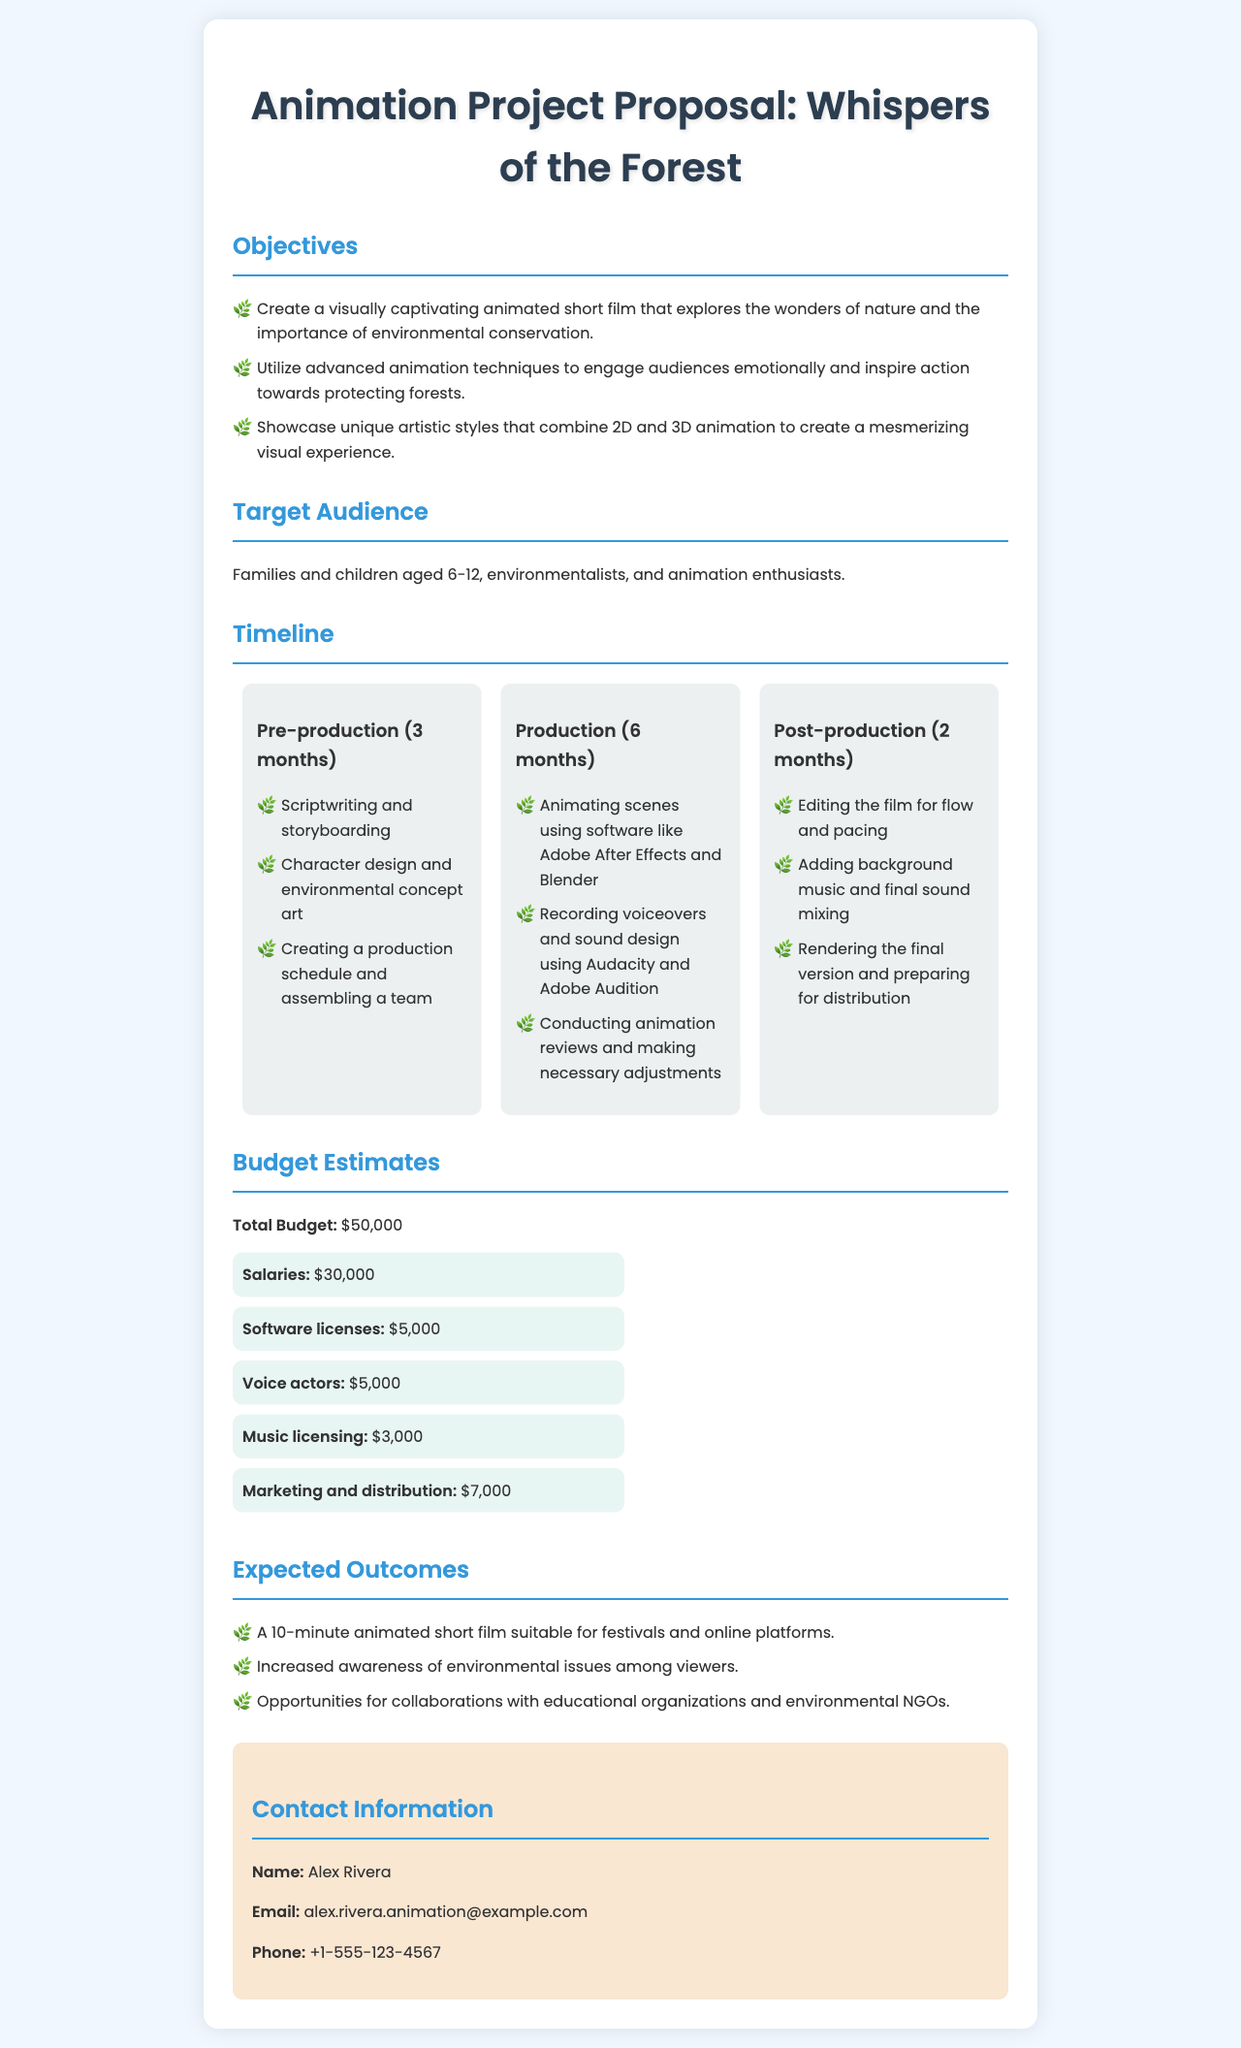What is the title of the project? The title of the project is mentioned at the top of the document as "Animation Project Proposal: Whispers of the Forest."
Answer: Whispers of the Forest What is the total budget for the project? The total budget is explicitly listed under the Budget Estimates section as $50,000.
Answer: $50,000 How long is the production phase scheduled to last? The production phase duration is specified as 6 months within the timeline section.
Answer: 6 months Who is the contact person for this proposal? The name of the contact person is provided in the Contact Information section.
Answer: Alex Rivera What is one of the objectives of the project? One of the objectives is to create a visually captivating animated short film that explores the wonders of nature and the importance of environmental conservation.
Answer: Create a visually captivating animated short film What specific techniques will be utilized in the animation? The proposal mentions the utilization of advanced animation techniques to engage audiences emotionally.
Answer: Advanced animation techniques What is the expected outcome regarding collaboration? The document states that there will be opportunities for collaborations with educational organizations and environmental NGOs.
Answer: Collaborations with educational organizations and environmental NGOs What is the budget allocation for marketing and distribution? The budget breakdown lists the allocation for marketing and distribution as $7,000.
Answer: $7,000 During which phase will character design occur? The character design is outlined as part of the pre-production phase in the timeline section.
Answer: Pre-production 